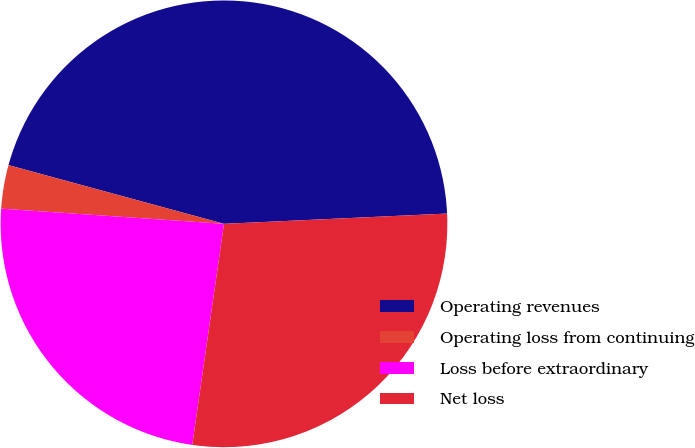Convert chart. <chart><loc_0><loc_0><loc_500><loc_500><pie_chart><fcel>Operating revenues<fcel>Operating loss from continuing<fcel>Loss before extraordinary<fcel>Net loss<nl><fcel>45.03%<fcel>3.15%<fcel>23.81%<fcel>28.0%<nl></chart> 